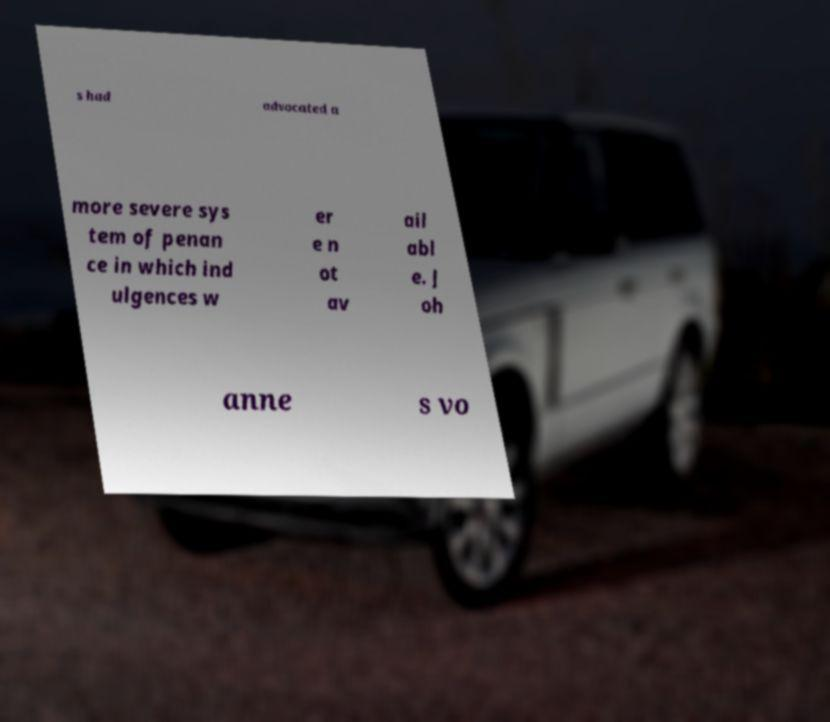Can you read and provide the text displayed in the image?This photo seems to have some interesting text. Can you extract and type it out for me? s had advocated a more severe sys tem of penan ce in which ind ulgences w er e n ot av ail abl e. J oh anne s vo 